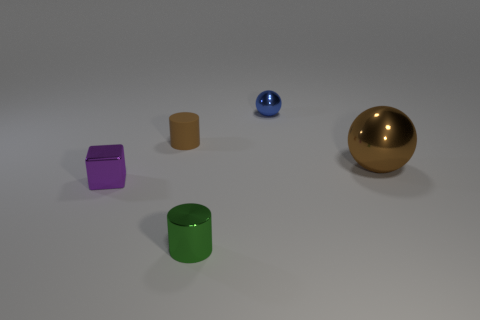Are there any other things that have the same material as the small brown cylinder?
Make the answer very short. No. Is there any other thing that has the same size as the brown metallic sphere?
Provide a succinct answer. No. There is a object right of the blue shiny thing; how big is it?
Your response must be concise. Large. What number of other objects are there of the same color as the tiny metal ball?
Offer a terse response. 0. What material is the tiny object to the right of the cylinder in front of the brown metal object?
Give a very brief answer. Metal. There is a small cylinder that is on the left side of the small green metal cylinder; does it have the same color as the tiny sphere?
Provide a short and direct response. No. How many tiny brown objects have the same shape as the tiny purple shiny thing?
Provide a short and direct response. 0. What size is the brown object that is the same material as the purple cube?
Your response must be concise. Large. There is a brown object that is left of the cylinder in front of the tiny matte object; is there a small blue sphere that is in front of it?
Offer a very short reply. No. There is a brown object on the right side of the rubber thing; is its size the same as the tiny cube?
Offer a very short reply. No. 